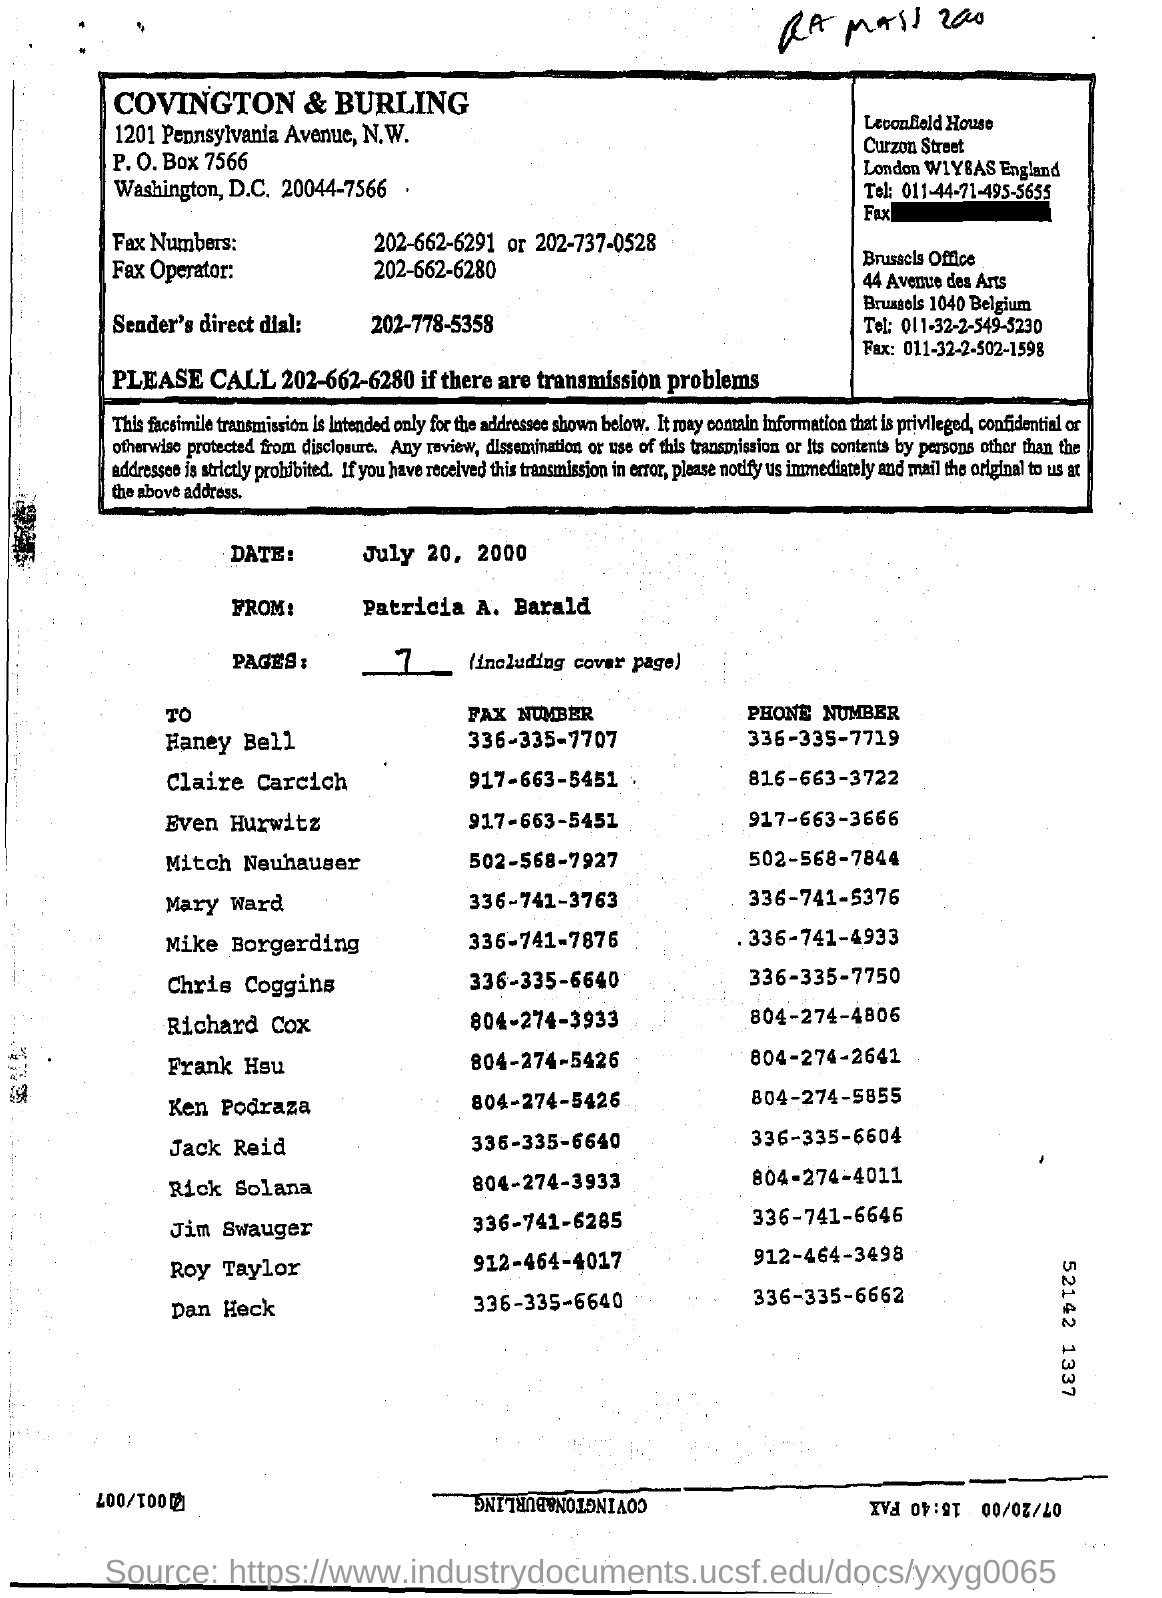Draw attention to some important aspects in this diagram. The fax number of Even Hurwitz is 917-663-5451. This text contains 7 pages that have been handwritten. The date printed on this page is July 20, 2000. The sender's direct dial number is 202-778-5358. 